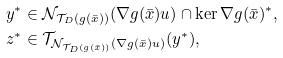<formula> <loc_0><loc_0><loc_500><loc_500>y ^ { * } & \in \mathcal { N } _ { \mathcal { T } _ { D } ( g ( \bar { x } ) ) } ( \nabla g ( \bar { x } ) u ) \cap \ker \nabla g ( \bar { x } ) ^ { * } , \\ z ^ { * } & \in \mathcal { T } _ { \mathcal { N } _ { \mathcal { T } _ { D } ( g ( \bar { x } ) ) } ( \nabla g ( \bar { x } ) u ) } ( y ^ { * } ) ,</formula> 